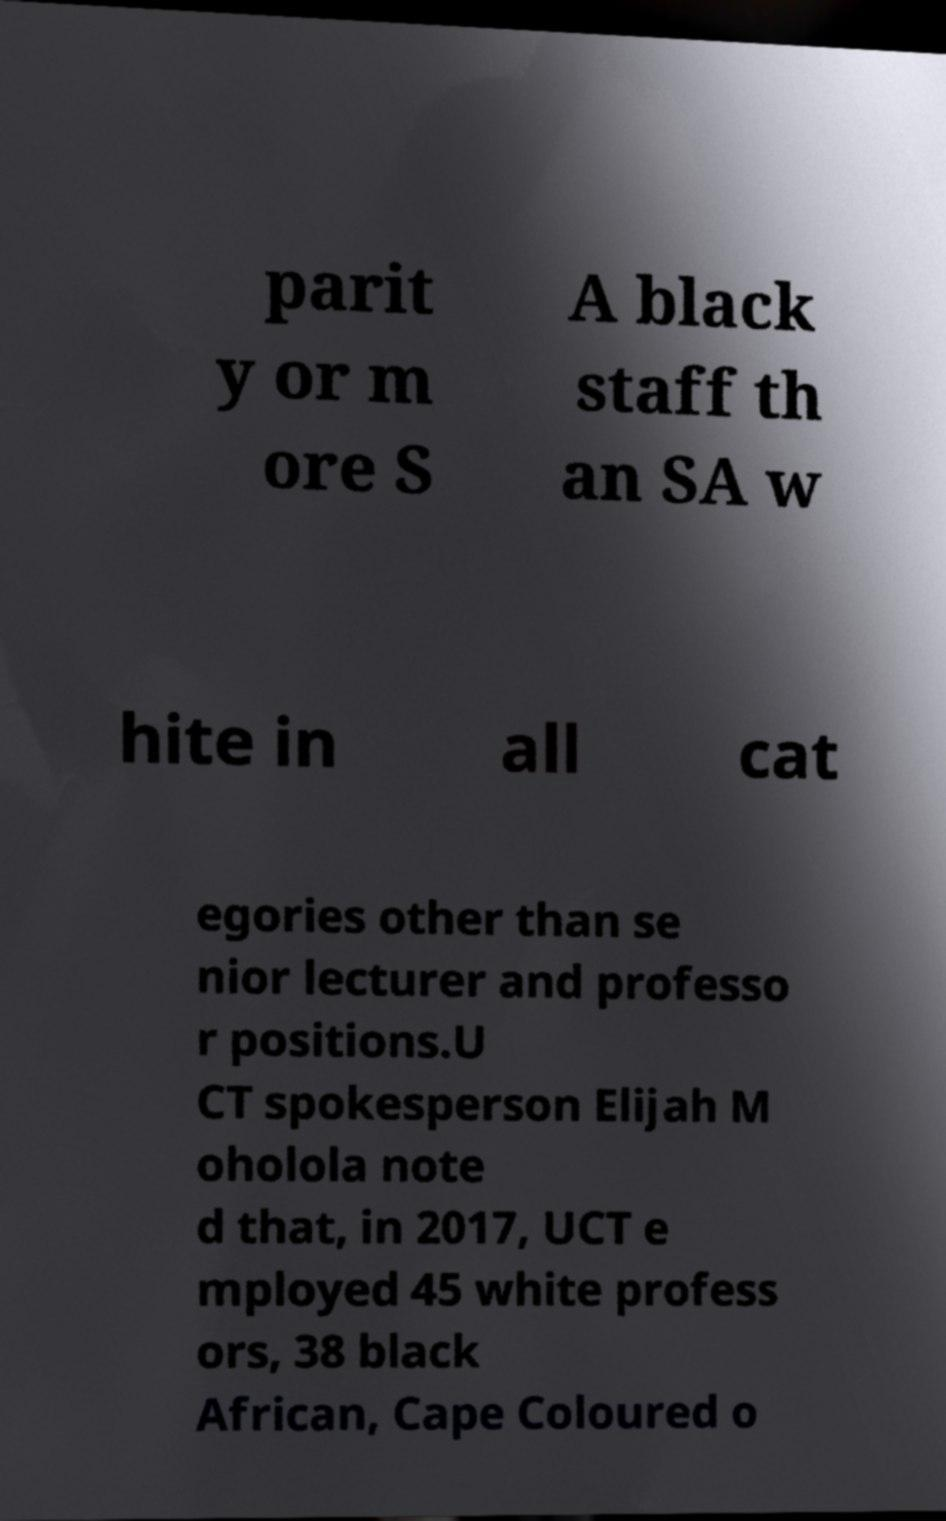For documentation purposes, I need the text within this image transcribed. Could you provide that? parit y or m ore S A black staff th an SA w hite in all cat egories other than se nior lecturer and professo r positions.U CT spokesperson Elijah M oholola note d that, in 2017, UCT e mployed 45 white profess ors, 38 black African, Cape Coloured o 